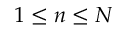<formula> <loc_0><loc_0><loc_500><loc_500>1 \leq n \leq N</formula> 